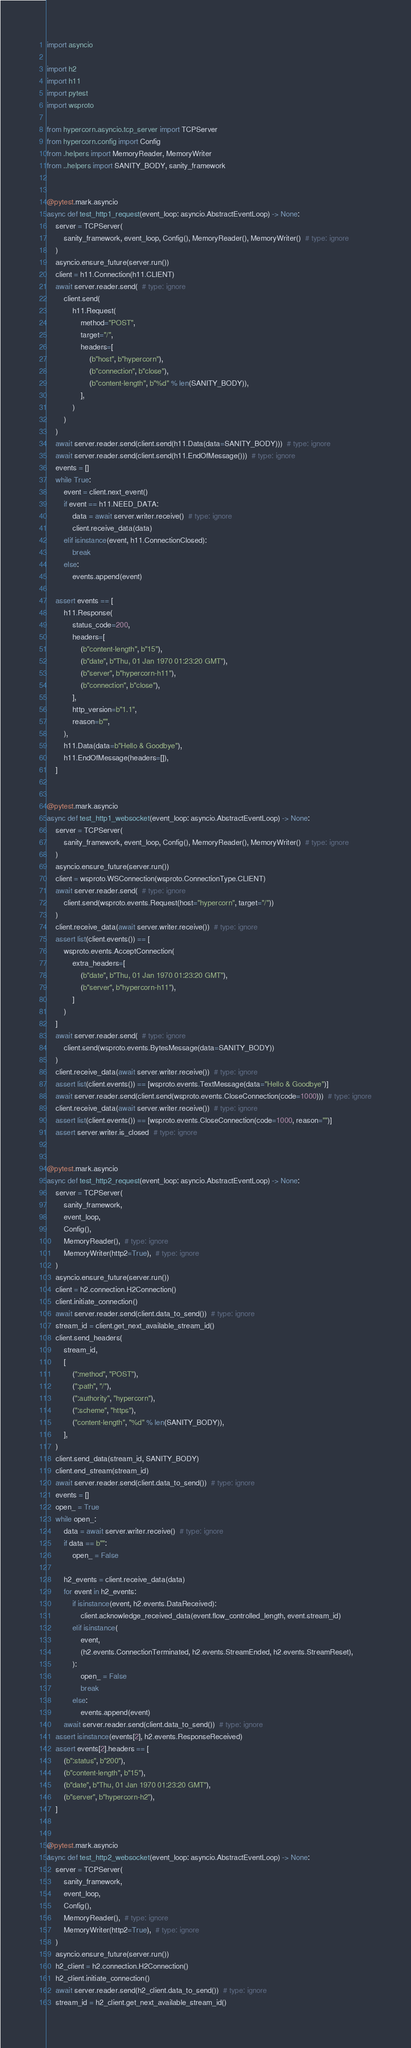Convert code to text. <code><loc_0><loc_0><loc_500><loc_500><_Python_>import asyncio

import h2
import h11
import pytest
import wsproto

from hypercorn.asyncio.tcp_server import TCPServer
from hypercorn.config import Config
from .helpers import MemoryReader, MemoryWriter
from ..helpers import SANITY_BODY, sanity_framework


@pytest.mark.asyncio
async def test_http1_request(event_loop: asyncio.AbstractEventLoop) -> None:
    server = TCPServer(
        sanity_framework, event_loop, Config(), MemoryReader(), MemoryWriter()  # type: ignore
    )
    asyncio.ensure_future(server.run())
    client = h11.Connection(h11.CLIENT)
    await server.reader.send(  # type: ignore
        client.send(
            h11.Request(
                method="POST",
                target="/",
                headers=[
                    (b"host", b"hypercorn"),
                    (b"connection", b"close"),
                    (b"content-length", b"%d" % len(SANITY_BODY)),
                ],
            )
        )
    )
    await server.reader.send(client.send(h11.Data(data=SANITY_BODY)))  # type: ignore
    await server.reader.send(client.send(h11.EndOfMessage()))  # type: ignore
    events = []
    while True:
        event = client.next_event()
        if event == h11.NEED_DATA:
            data = await server.writer.receive()  # type: ignore
            client.receive_data(data)
        elif isinstance(event, h11.ConnectionClosed):
            break
        else:
            events.append(event)

    assert events == [
        h11.Response(
            status_code=200,
            headers=[
                (b"content-length", b"15"),
                (b"date", b"Thu, 01 Jan 1970 01:23:20 GMT"),
                (b"server", b"hypercorn-h11"),
                (b"connection", b"close"),
            ],
            http_version=b"1.1",
            reason=b"",
        ),
        h11.Data(data=b"Hello & Goodbye"),
        h11.EndOfMessage(headers=[]),
    ]


@pytest.mark.asyncio
async def test_http1_websocket(event_loop: asyncio.AbstractEventLoop) -> None:
    server = TCPServer(
        sanity_framework, event_loop, Config(), MemoryReader(), MemoryWriter()  # type: ignore
    )
    asyncio.ensure_future(server.run())
    client = wsproto.WSConnection(wsproto.ConnectionType.CLIENT)
    await server.reader.send(  # type: ignore
        client.send(wsproto.events.Request(host="hypercorn", target="/"))
    )
    client.receive_data(await server.writer.receive())  # type: ignore
    assert list(client.events()) == [
        wsproto.events.AcceptConnection(
            extra_headers=[
                (b"date", b"Thu, 01 Jan 1970 01:23:20 GMT"),
                (b"server", b"hypercorn-h11"),
            ]
        )
    ]
    await server.reader.send(  # type: ignore
        client.send(wsproto.events.BytesMessage(data=SANITY_BODY))
    )
    client.receive_data(await server.writer.receive())  # type: ignore
    assert list(client.events()) == [wsproto.events.TextMessage(data="Hello & Goodbye")]
    await server.reader.send(client.send(wsproto.events.CloseConnection(code=1000)))  # type: ignore
    client.receive_data(await server.writer.receive())  # type: ignore
    assert list(client.events()) == [wsproto.events.CloseConnection(code=1000, reason="")]
    assert server.writer.is_closed  # type: ignore


@pytest.mark.asyncio
async def test_http2_request(event_loop: asyncio.AbstractEventLoop) -> None:
    server = TCPServer(
        sanity_framework,
        event_loop,
        Config(),
        MemoryReader(),  # type: ignore
        MemoryWriter(http2=True),  # type: ignore
    )
    asyncio.ensure_future(server.run())
    client = h2.connection.H2Connection()
    client.initiate_connection()
    await server.reader.send(client.data_to_send())  # type: ignore
    stream_id = client.get_next_available_stream_id()
    client.send_headers(
        stream_id,
        [
            (":method", "POST"),
            (":path", "/"),
            (":authority", "hypercorn"),
            (":scheme", "https"),
            ("content-length", "%d" % len(SANITY_BODY)),
        ],
    )
    client.send_data(stream_id, SANITY_BODY)
    client.end_stream(stream_id)
    await server.reader.send(client.data_to_send())  # type: ignore
    events = []
    open_ = True
    while open_:
        data = await server.writer.receive()  # type: ignore
        if data == b"":
            open_ = False

        h2_events = client.receive_data(data)
        for event in h2_events:
            if isinstance(event, h2.events.DataReceived):
                client.acknowledge_received_data(event.flow_controlled_length, event.stream_id)
            elif isinstance(
                event,
                (h2.events.ConnectionTerminated, h2.events.StreamEnded, h2.events.StreamReset),
            ):
                open_ = False
                break
            else:
                events.append(event)
        await server.reader.send(client.data_to_send())  # type: ignore
    assert isinstance(events[2], h2.events.ResponseReceived)
    assert events[2].headers == [
        (b":status", b"200"),
        (b"content-length", b"15"),
        (b"date", b"Thu, 01 Jan 1970 01:23:20 GMT"),
        (b"server", b"hypercorn-h2"),
    ]


@pytest.mark.asyncio
async def test_http2_websocket(event_loop: asyncio.AbstractEventLoop) -> None:
    server = TCPServer(
        sanity_framework,
        event_loop,
        Config(),
        MemoryReader(),  # type: ignore
        MemoryWriter(http2=True),  # type: ignore
    )
    asyncio.ensure_future(server.run())
    h2_client = h2.connection.H2Connection()
    h2_client.initiate_connection()
    await server.reader.send(h2_client.data_to_send())  # type: ignore
    stream_id = h2_client.get_next_available_stream_id()</code> 